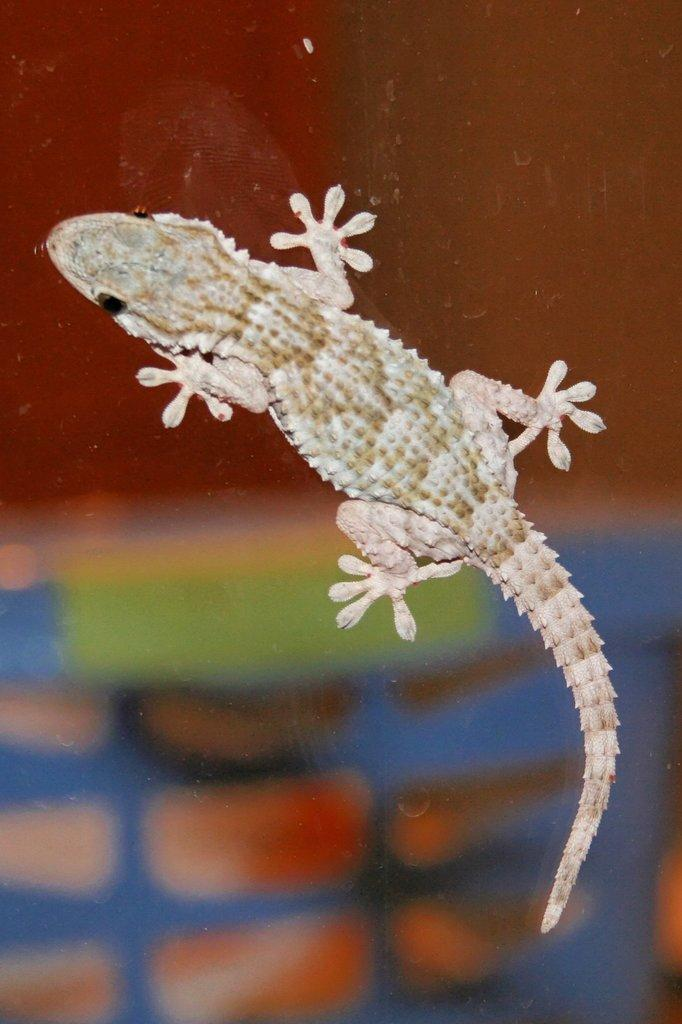What type of animal is in the image? There is a reptile in the image. What is the reptile resting on? The reptile is on a glass surface. Can you describe the background of the image? The background of the image is blurry. What type of yak can be seen grazing in the background of the image? There is no yak present in the image; it features a reptile on a glass surface with a blurry background. 